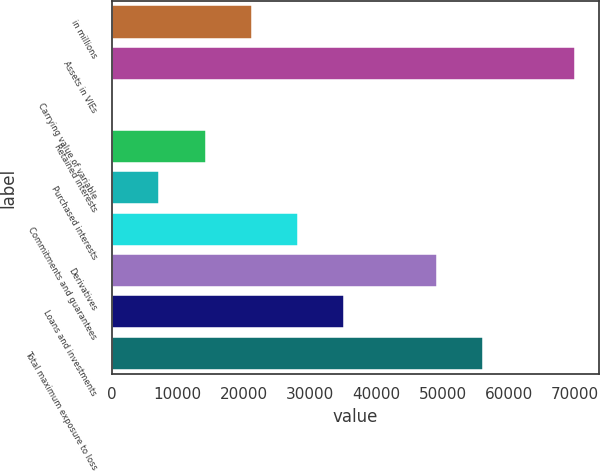Convert chart. <chart><loc_0><loc_0><loc_500><loc_500><bar_chart><fcel>in millions<fcel>Assets in VIEs<fcel>Carrying value of variable<fcel>Retained interests<fcel>Purchased interests<fcel>Commitments and guarantees<fcel>Derivatives<fcel>Loans and investments<fcel>Total maximum exposure to loss<nl><fcel>21202.7<fcel>70083<fcel>254<fcel>14219.8<fcel>7236.9<fcel>28185.6<fcel>49134.3<fcel>35168.5<fcel>56117.2<nl></chart> 